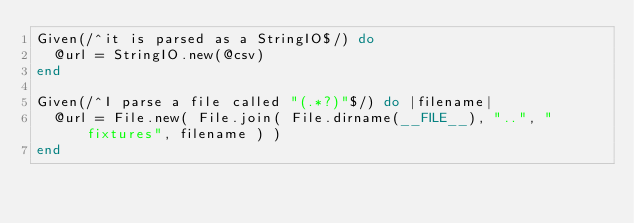Convert code to text. <code><loc_0><loc_0><loc_500><loc_500><_Ruby_>Given(/^it is parsed as a StringIO$/) do
  @url = StringIO.new(@csv)
end

Given(/^I parse a file called "(.*?)"$/) do |filename|
  @url = File.new( File.join( File.dirname(__FILE__), "..", "fixtures", filename ) )
end
</code> 